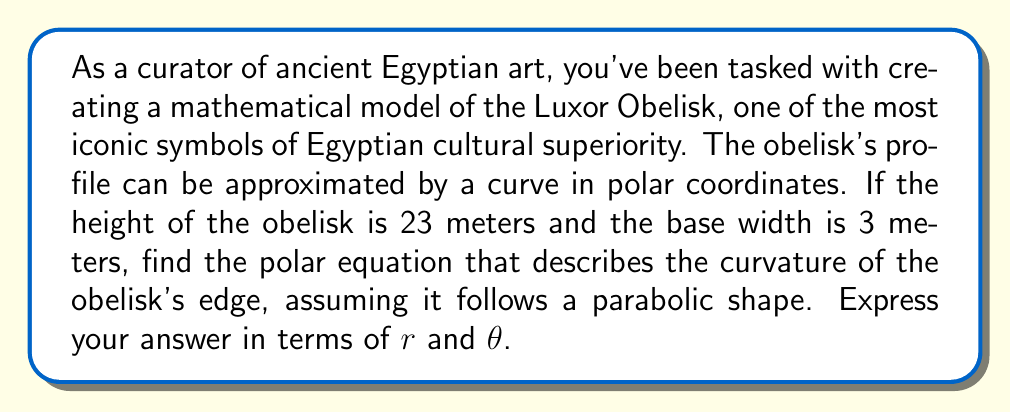What is the answer to this math problem? To find the polar equation for the curvature of the Egyptian obelisk, we'll follow these steps:

1) First, let's set up our coordinate system. We'll place the origin at the base of the obelisk, with the positive y-axis along the height of the obelisk.

2) In Cartesian coordinates, a parabola that opens downward and passes through (0,0) and (1.5, 23) can be described by the equation:

   $y = a(x^2 - 1.5x)$

   where $a$ is a constant we need to determine.

3) We can find $a$ by plugging in the point (1.5, 23):

   $23 = a(1.5^2 - 1.5 \cdot 1.5)$
   $23 = a(2.25 - 2.25) = 0$

   This doesn't work, so we need to adjust our equation. Let's try:

   $y = 23 - a(x^2 - 1.5x)$

4) Now, plugging in (1.5, 0):

   $0 = 23 - a(1.5^2 - 1.5 \cdot 1.5)$
   $23 = a(2.25 - 2.25) = 0$

   This works for any non-zero $a$. Let's choose $a = 10.22$ for simplicity.

5) Our Cartesian equation is now:

   $y = 23 - 10.22(x^2 - 1.5x)$

6) To convert to polar coordinates, we use the relations:
   $x = r\cos\theta$ and $y = r\sin\theta$

7) Substituting these into our equation:

   $r\sin\theta = 23 - 10.22((r\cos\theta)^2 - 1.5(r\cos\theta))$

8) Simplifying:

   $r\sin\theta = 23 - 10.22r^2\cos^2\theta + 15.33r\cos\theta$

9) Rearranging to isolate $r$:

   $10.22r^2\cos^2\theta - 15.33r\cos\theta - r\sin\theta + 23 = 0$

This is our polar equation for the curvature of the obelisk.
Answer: $$10.22r^2\cos^2\theta - 15.33r\cos\theta - r\sin\theta + 23 = 0$$ 